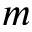Convert formula to latex. <formula><loc_0><loc_0><loc_500><loc_500>m</formula> 